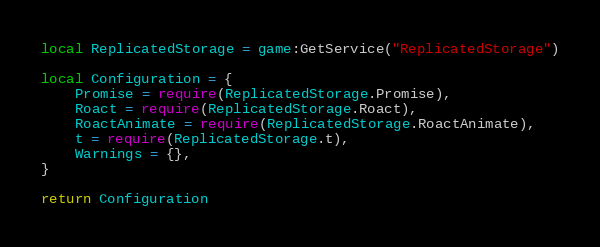Convert code to text. <code><loc_0><loc_0><loc_500><loc_500><_Lua_>local ReplicatedStorage = game:GetService("ReplicatedStorage")

local Configuration = {
	Promise = require(ReplicatedStorage.Promise),
	Roact = require(ReplicatedStorage.Roact),
	RoactAnimate = require(ReplicatedStorage.RoactAnimate),
	t = require(ReplicatedStorage.t),
	Warnings = {},
}

return Configuration
</code> 